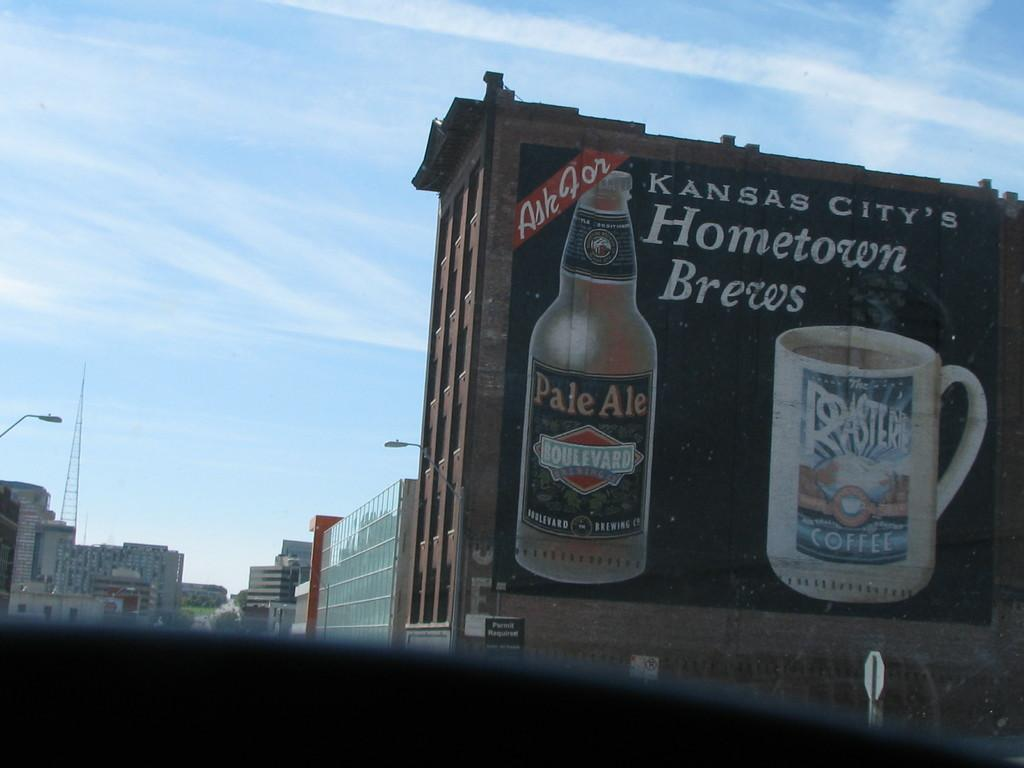What can be seen in the image? There are many buildings in the image. Can you describe any specific details about the buildings? There is an advertisement on one of the buildings, featuring a bottle and a cup. What is visible in the background of the image? There is a tower and the sky visible in the background of the image. What is the condition of the sky in the image? The sky is visible in the background of the image, and clouds are present. What type of attention is the bedroom receiving in the image? There is no bedroom present in the image; it features many buildings, an advertisement, a tower, and the sky. What causes the burst of colors in the image? There is no burst of colors in the image; the colors are consistent and muted, with the exception of the advertisement featuring a bottle and a cup. 